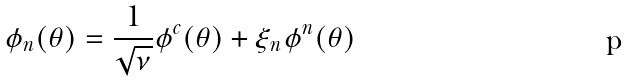Convert formula to latex. <formula><loc_0><loc_0><loc_500><loc_500>\phi _ { n } ( \theta ) = \frac { 1 } { \sqrt { \nu } } \phi ^ { c } ( \theta ) + \xi _ { n } \phi ^ { n } ( \theta )</formula> 